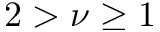Convert formula to latex. <formula><loc_0><loc_0><loc_500><loc_500>2 > \nu \geq 1</formula> 